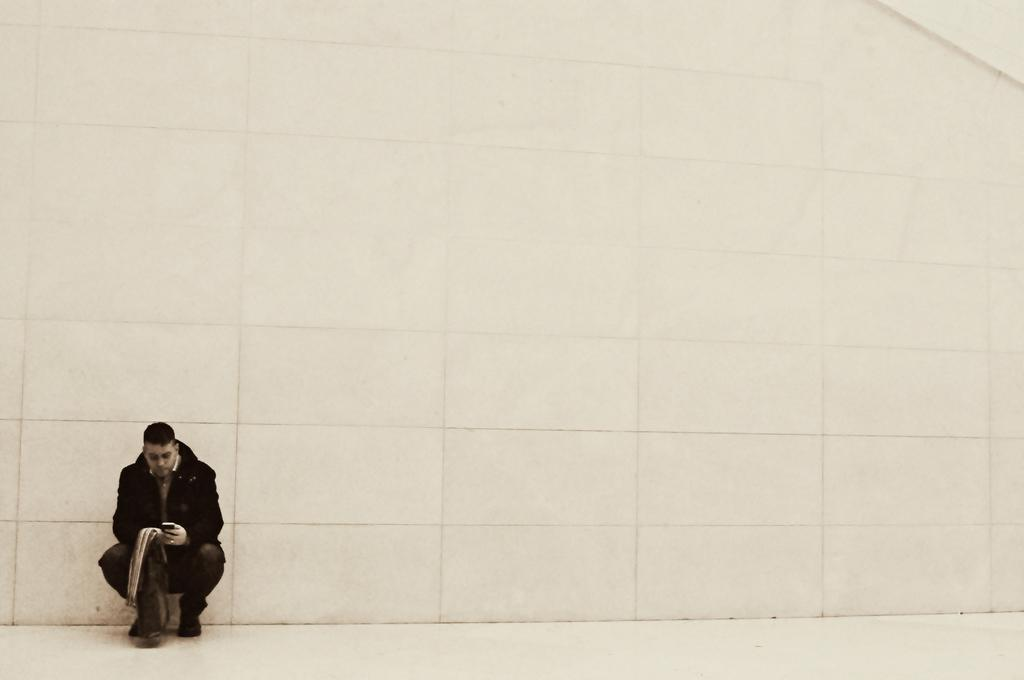What is the main subject of the image? There is a person in the image. What is the person doing in the image? The person is in a squat position. What is the person holding in the image? The person is holding some objects. What is visible beneath the person in the image? There is a floor visible in the image. What can be seen behind the person in the image? There is a wall in the background of the image. What type of steel is being used to construct the train in the image? There is no train present in the image; it features a person in a squat position holding objects. How many apples can be seen in the person's hand in the image? The image does not show any apples; the person is holding unspecified objects. 